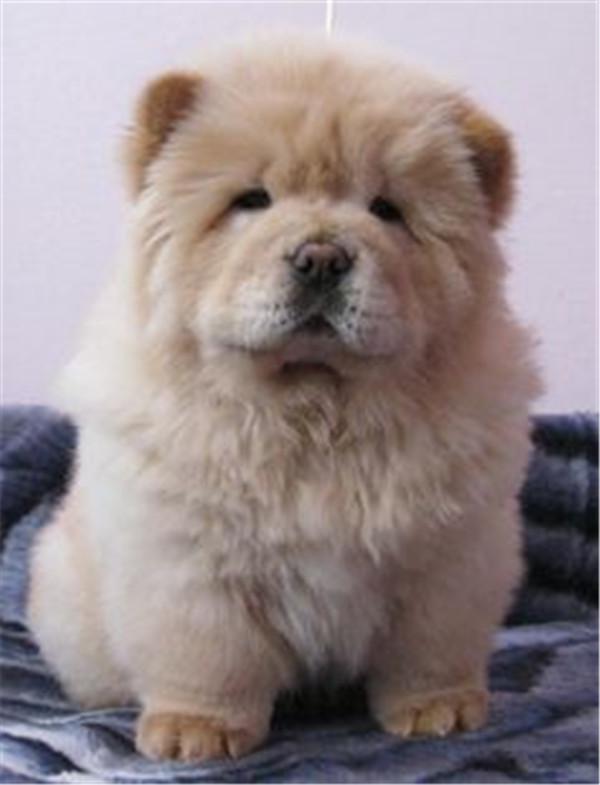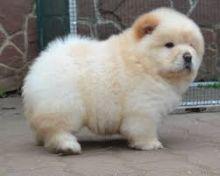The first image is the image on the left, the second image is the image on the right. Given the left and right images, does the statement "The right image shows a pale cream-colored chow pup standing on all fours." hold true? Answer yes or no. Yes. 